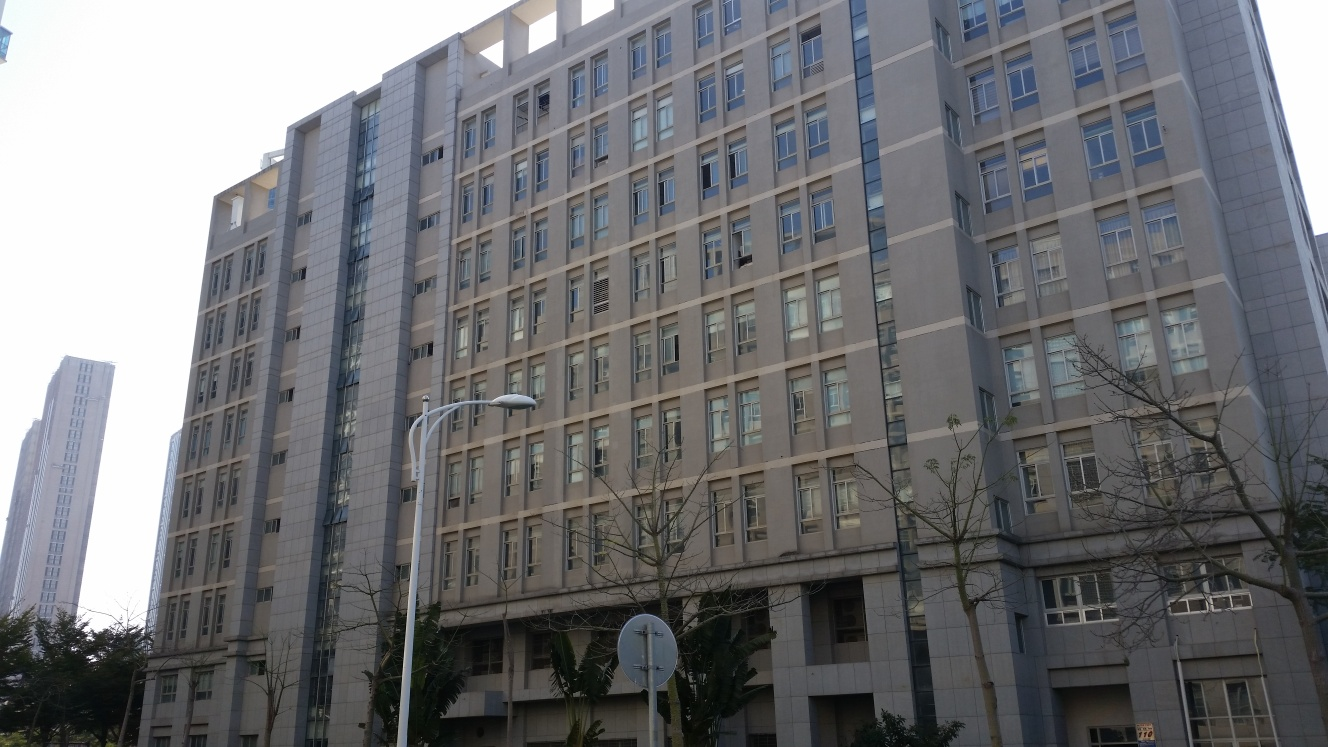Can you discuss the time of day this photo might have been taken and how that impacts the image's aesthetics? This photo likely was taken in the mid-morning, as indicated by the bright yet soft lighting and the lack of long shadows which suggests the sun is fairly high in the sky. This timing helps in reducing glare and allows for the details of the building’s façade to be captured clearly. The gentle lighting enhances the building's features without creating harsh contrasts or deep shadows, which contributes to the overall serene and straightforward presentation of the urban landscape. 